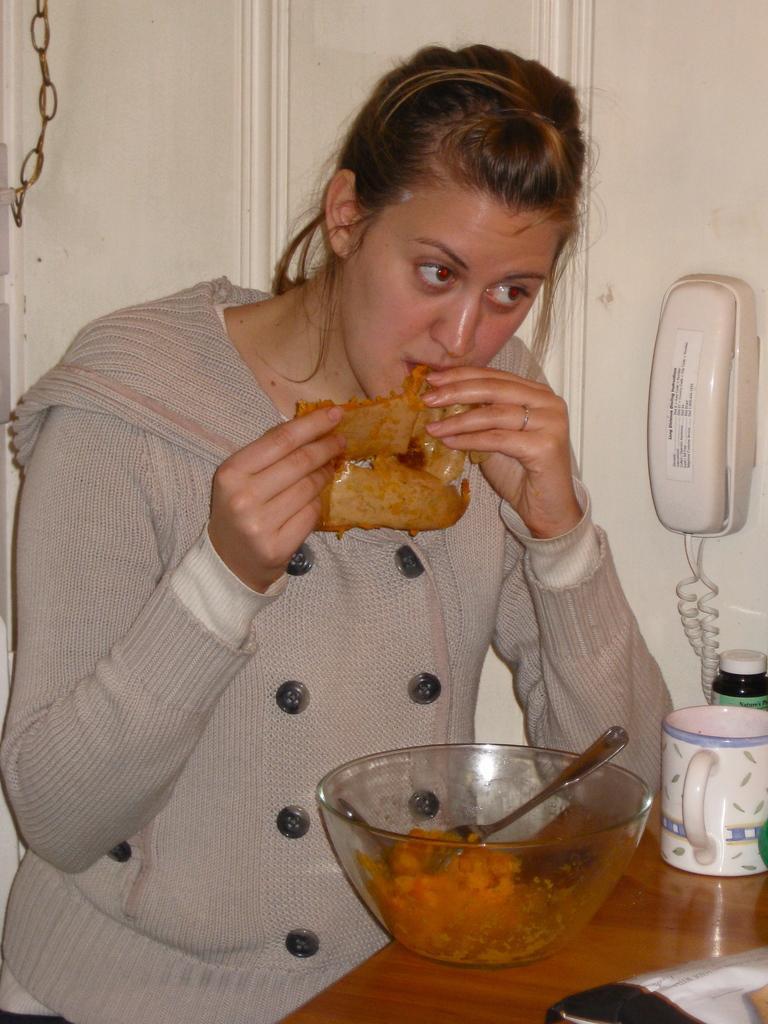Could you give a brief overview of what you see in this image? In this image we can see a lady person eating some food item, there is some food item in a bowl, there is coffee glass and some other item on table and in the background of the image there is a telephone which is attached to the wall and there is a door. 